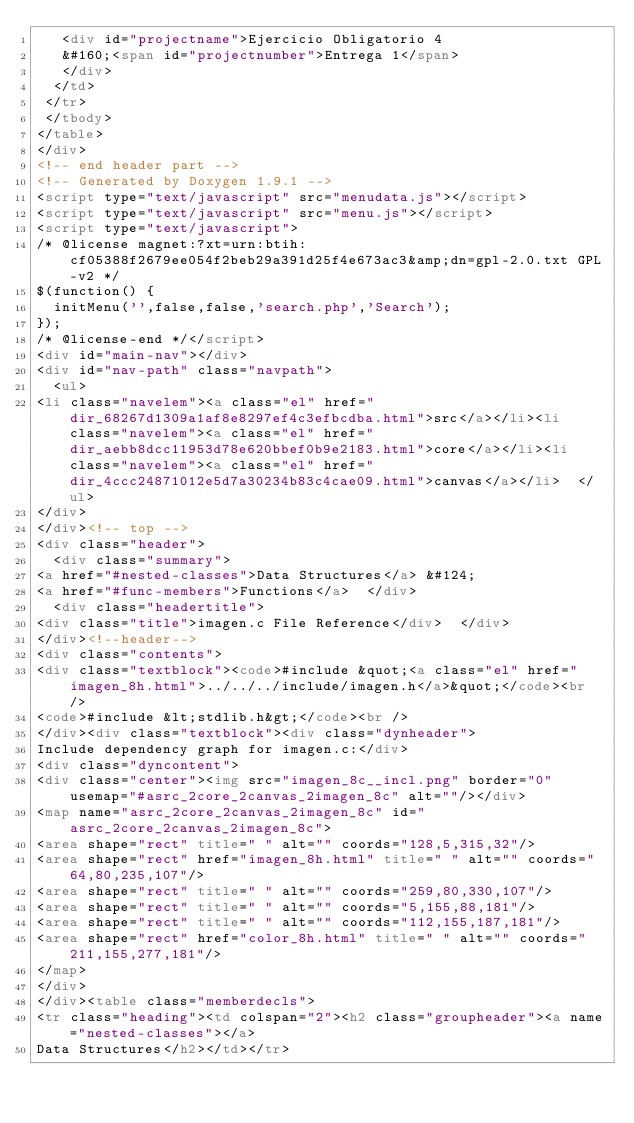Convert code to text. <code><loc_0><loc_0><loc_500><loc_500><_HTML_>   <div id="projectname">Ejercicio Obligatorio 4
   &#160;<span id="projectnumber">Entrega 1</span>
   </div>
  </td>
 </tr>
 </tbody>
</table>
</div>
<!-- end header part -->
<!-- Generated by Doxygen 1.9.1 -->
<script type="text/javascript" src="menudata.js"></script>
<script type="text/javascript" src="menu.js"></script>
<script type="text/javascript">
/* @license magnet:?xt=urn:btih:cf05388f2679ee054f2beb29a391d25f4e673ac3&amp;dn=gpl-2.0.txt GPL-v2 */
$(function() {
  initMenu('',false,false,'search.php','Search');
});
/* @license-end */</script>
<div id="main-nav"></div>
<div id="nav-path" class="navpath">
  <ul>
<li class="navelem"><a class="el" href="dir_68267d1309a1af8e8297ef4c3efbcdba.html">src</a></li><li class="navelem"><a class="el" href="dir_aebb8dcc11953d78e620bbef0b9e2183.html">core</a></li><li class="navelem"><a class="el" href="dir_4ccc24871012e5d7a30234b83c4cae09.html">canvas</a></li>  </ul>
</div>
</div><!-- top -->
<div class="header">
  <div class="summary">
<a href="#nested-classes">Data Structures</a> &#124;
<a href="#func-members">Functions</a>  </div>
  <div class="headertitle">
<div class="title">imagen.c File Reference</div>  </div>
</div><!--header-->
<div class="contents">
<div class="textblock"><code>#include &quot;<a class="el" href="imagen_8h.html">../../../include/imagen.h</a>&quot;</code><br />
<code>#include &lt;stdlib.h&gt;</code><br />
</div><div class="textblock"><div class="dynheader">
Include dependency graph for imagen.c:</div>
<div class="dyncontent">
<div class="center"><img src="imagen_8c__incl.png" border="0" usemap="#asrc_2core_2canvas_2imagen_8c" alt=""/></div>
<map name="asrc_2core_2canvas_2imagen_8c" id="asrc_2core_2canvas_2imagen_8c">
<area shape="rect" title=" " alt="" coords="128,5,315,32"/>
<area shape="rect" href="imagen_8h.html" title=" " alt="" coords="64,80,235,107"/>
<area shape="rect" title=" " alt="" coords="259,80,330,107"/>
<area shape="rect" title=" " alt="" coords="5,155,88,181"/>
<area shape="rect" title=" " alt="" coords="112,155,187,181"/>
<area shape="rect" href="color_8h.html" title=" " alt="" coords="211,155,277,181"/>
</map>
</div>
</div><table class="memberdecls">
<tr class="heading"><td colspan="2"><h2 class="groupheader"><a name="nested-classes"></a>
Data Structures</h2></td></tr></code> 